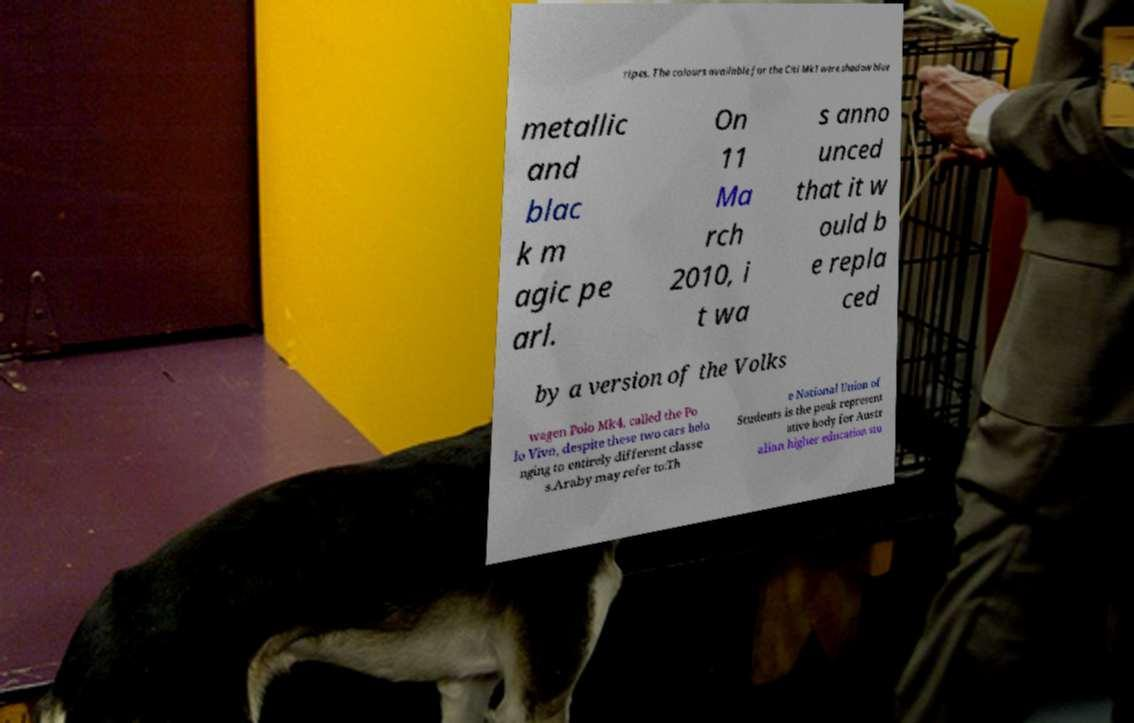There's text embedded in this image that I need extracted. Can you transcribe it verbatim? ripes. The colours available for the Citi Mk1 were shadow blue metallic and blac k m agic pe arl. On 11 Ma rch 2010, i t wa s anno unced that it w ould b e repla ced by a version of the Volks wagen Polo Mk4, called the Po lo Vivo, despite these two cars belo nging to entirely different classe s.Araby may refer to:Th e National Union of Students is the peak represent ative body for Austr alian higher education stu 